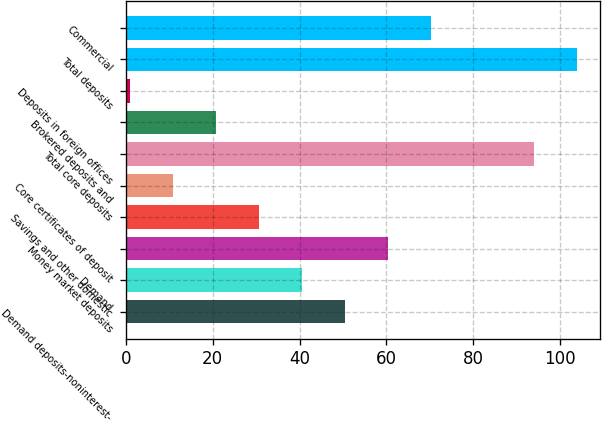<chart> <loc_0><loc_0><loc_500><loc_500><bar_chart><fcel>Demand deposits-noninterest-<fcel>Demand<fcel>Money market deposits<fcel>Savings and other domestic<fcel>Core certificates of deposit<fcel>Total core deposits<fcel>Brokered deposits and<fcel>Deposits in foreign offices<fcel>Total deposits<fcel>Commercial<nl><fcel>50.5<fcel>40.6<fcel>60.4<fcel>30.7<fcel>10.9<fcel>94<fcel>20.8<fcel>1<fcel>103.9<fcel>70.3<nl></chart> 